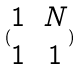Convert formula to latex. <formula><loc_0><loc_0><loc_500><loc_500>( \begin{matrix} 1 & N \\ 1 & 1 \end{matrix} )</formula> 